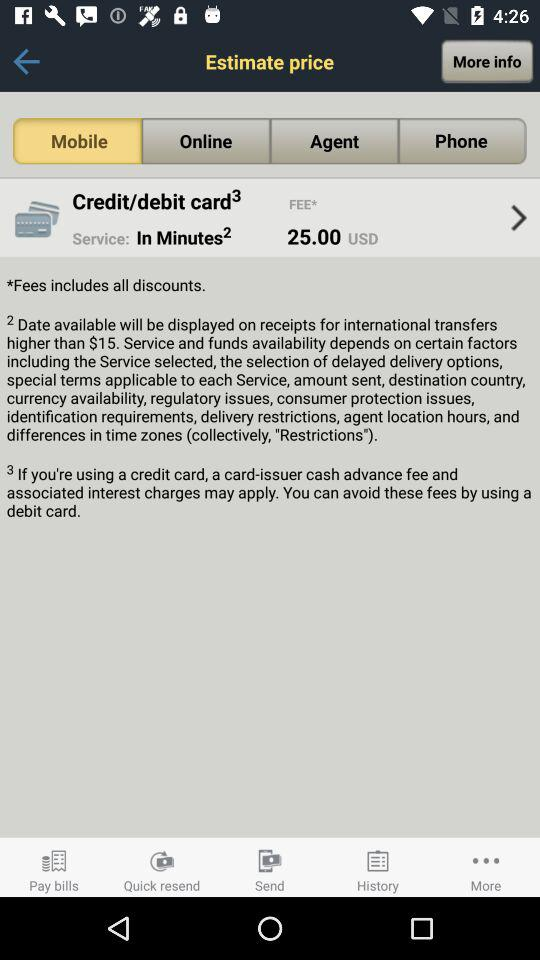What is the fee? The fee is 25 USD. 